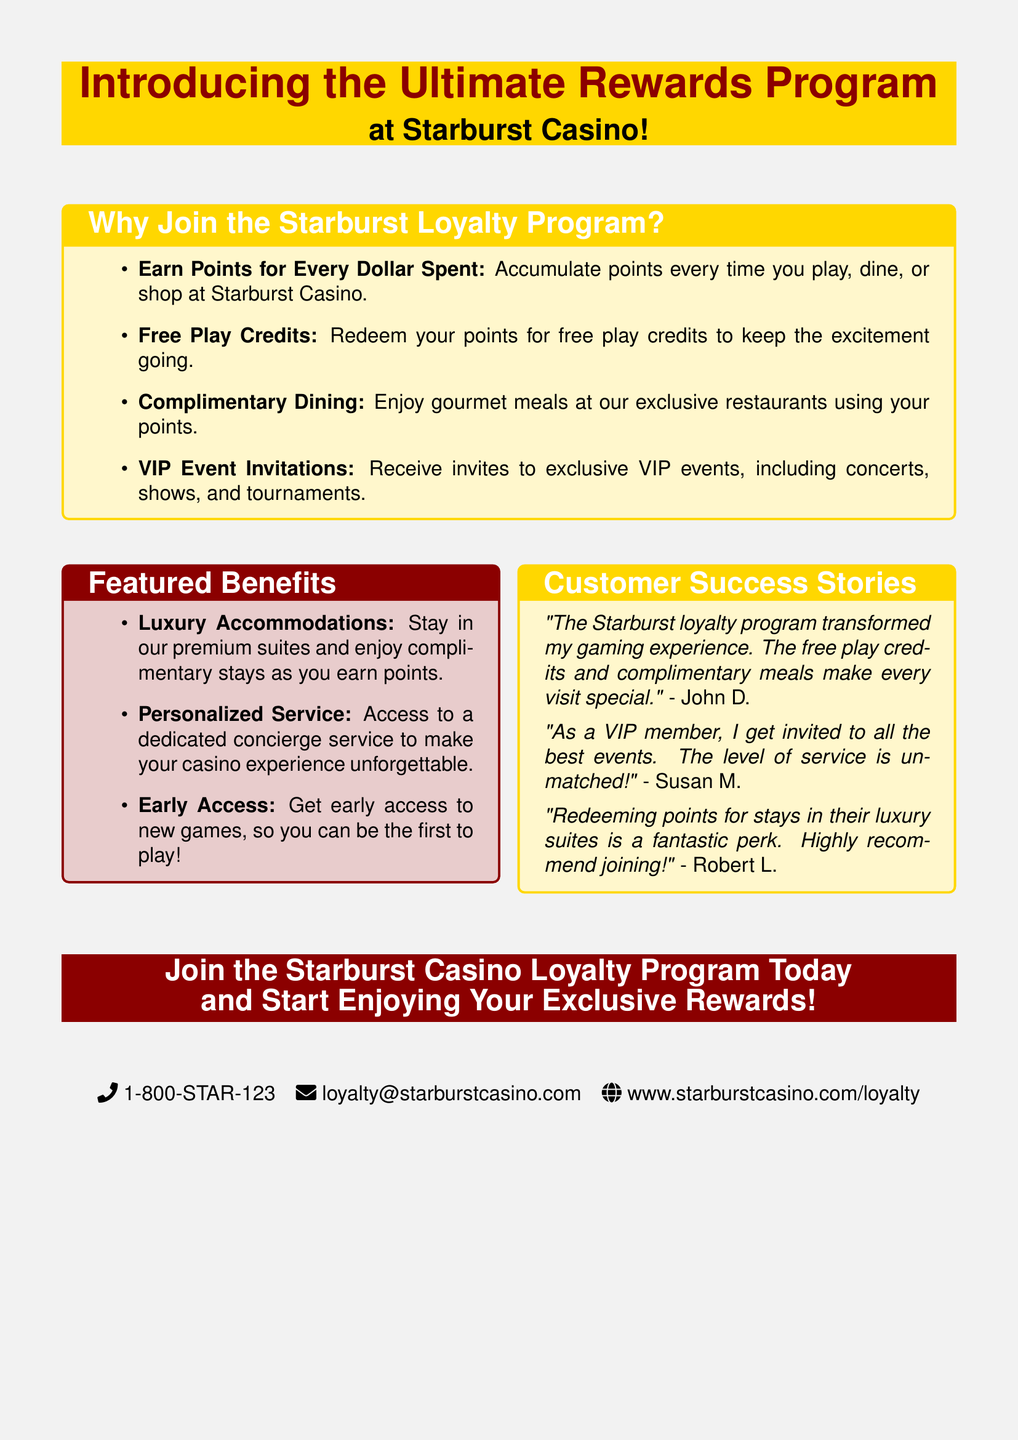What is the name of the casino? The document prominently features the name of the casino in the title section.
Answer: Starburst Casino What color frames the Customer Success Stories box? The document specifies the color used for the Customer Success Stories box in the document details.
Answer: casinogold How many benefits are listed in the Featured Benefits section? The number of items in the Featured Benefits section indicates the total benefits offered.
Answer: 3 What type of service is highlighted as part of the featured benefits? The document mentions a specific type of service that enhances the gaming experience, referenced in the benefits.
Answer: Concierge service Who is quoted in the Customer Success Stories section? The document includes quotes from specific individuals who share their experiences with the loyalty program.
Answer: John D., Susan M., Robert L What can members redeem their points for? The document specifies what members can exchange their accumulated points for in the loyalty program.
Answer: Free play credits What is the last call to action in the document? The final section of the document encourages a specific action for potential members regarding the loyalty program.
Answer: Join the Starburst Casino Loyalty Program Today What kind of events are VIP members invited to? The document describes a specific type of event that VIP members have access to, which illustrates the exclusivity of the program.
Answer: Exclusive VIP events 